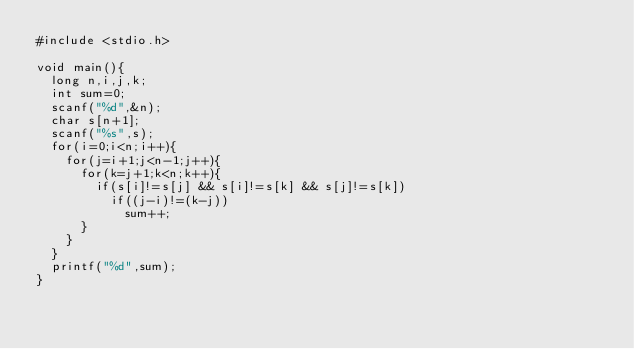<code> <loc_0><loc_0><loc_500><loc_500><_C_>#include <stdio.h>
 
void main(){
  long n,i,j,k;
  int sum=0;
  scanf("%d",&n);
  char s[n+1];
  scanf("%s",s);
  for(i=0;i<n;i++){
    for(j=i+1;j<n-1;j++){
      for(k=j+1;k<n;k++){
        if(s[i]!=s[j] && s[i]!=s[k] && s[j]!=s[k])
          if((j-i)!=(k-j))
            sum++;
      }
    }
  }
  printf("%d",sum);
}
</code> 